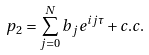<formula> <loc_0><loc_0><loc_500><loc_500>p _ { 2 } = \sum _ { j = 0 } ^ { N } b _ { j } e ^ { i j \tau } + c . c .</formula> 